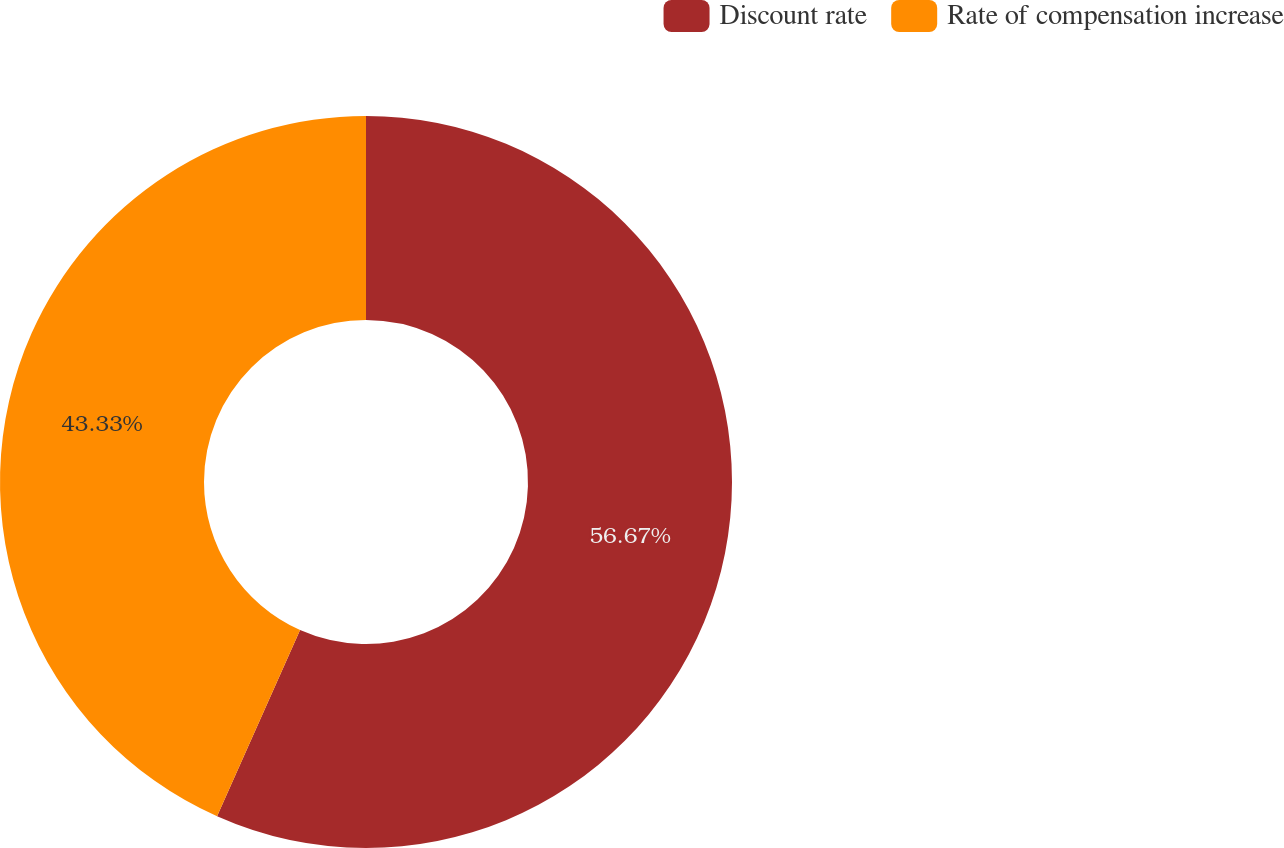<chart> <loc_0><loc_0><loc_500><loc_500><pie_chart><fcel>Discount rate<fcel>Rate of compensation increase<nl><fcel>56.67%<fcel>43.33%<nl></chart> 